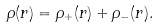Convert formula to latex. <formula><loc_0><loc_0><loc_500><loc_500>\rho ( r ) = \rho _ { + } ( r ) + \rho _ { - } ( r ) .</formula> 